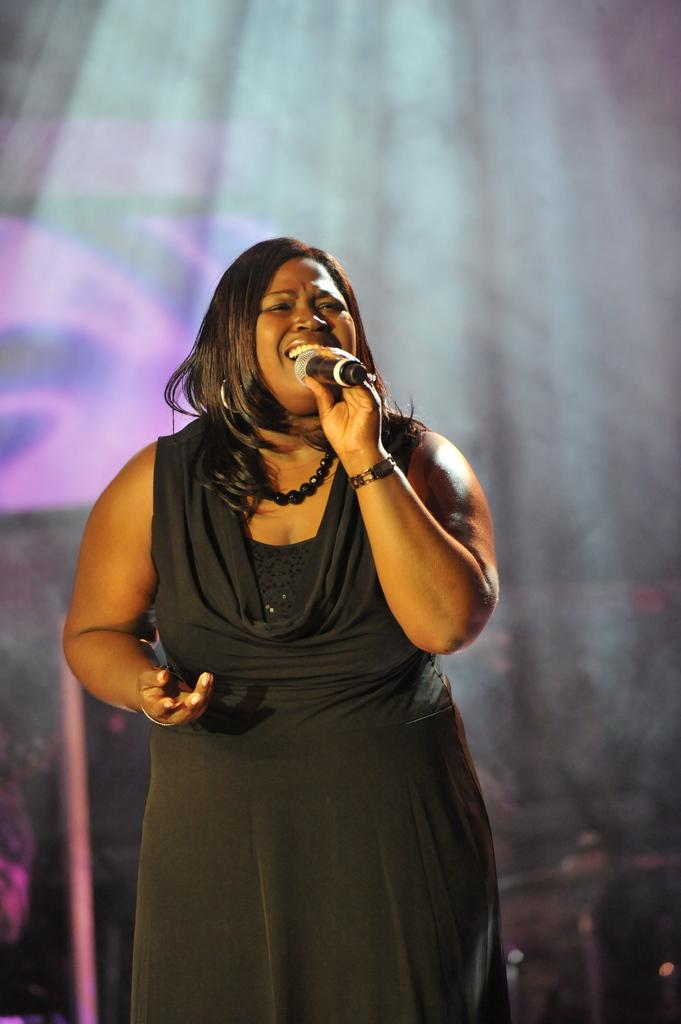Who is the main subject in the image? There is a woman in the image. What is the woman doing in the image? The woman is singing in the image. What tool is the woman using while singing? The woman is using a microphone in the image. How many boys are visible in the image? There are no boys visible in the image; it features a woman singing with a microphone. Can you see any wounds on the woman in the image? There is no indication of any wounds on the woman in the image. 